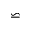<formula> <loc_0><loc_0><loc_500><loc_500>\backsimeq</formula> 